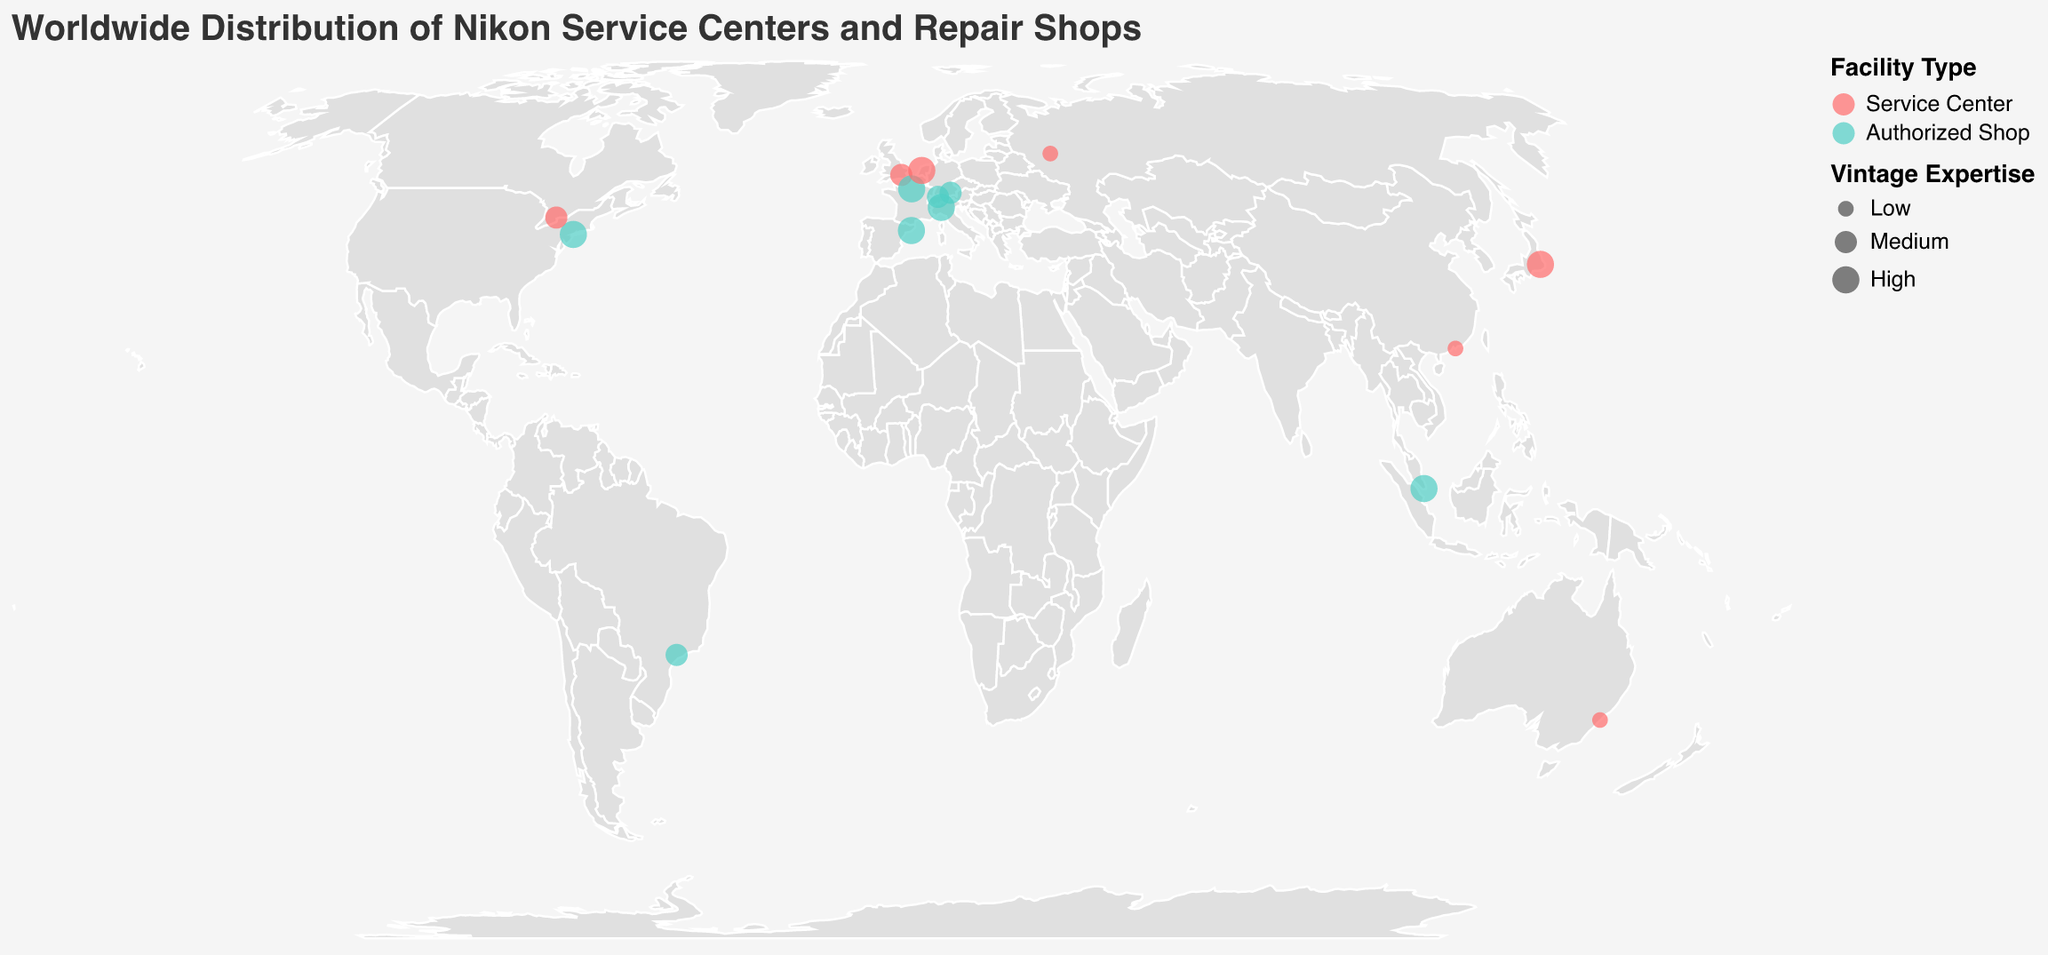Which countries have Nikon-related facilities with high vintage expertise? The "Vintage Expertise" legend in the figure shows that high expertise is represented by the largest circle size. High expertise can be seen in facilities located in Japan, USA, France, Italy, Spain, Netherlands, and Singapore.
Answer: Japan, USA, France, Italy, Spain, Netherlands, Singapore How many service centers are there worldwide? The "Facility Type" legend shows that service centers are in red. By counting the red circles on the map, there are eight service centers: located in Japan, UK, Australia, Canada, Netherlands, Hong Kong, Russia, and the USA.
Answer: 8 Which facility in Europe has the highest vintage expertise? In Europe, the largest circles (indicating high vintage expertise) are in Munich, Paris, Milan, and Amsterdam. Checking the map, Nikon European Center in Amsterdam is a service center, and the others are authorized shops. The facility in Amsterdam is the one with the highest vintage expertise in Europe.
Answer: Nikon European Center Which service center has the lowest vintage expertise? The "Vintage Expertise" legend shows that the smallest circle size represents low expertise. The service centers with the smallest circles are in Sydney, Hong Kong, and Moscow. All three service centers have the lowest vintage expertise.
Answer: Sydney, Hong Kong, Moscow Which city has the largest number of Nikon-related facilities displayed? The tooltip information as you hover reveals that each facility's city name. By counting, only one city, each, hosts the facilities. Therefore, the answer is every city has only 1 Nikon-related facility displayed.
Answer: Each city has 1 Which continent has the highest concentration of high-expertise authorized shops? Checking the map for green circles with the largest size in Europe shows authorized shops in Munich, Paris, Milan, and Zurich. Europe has the highest concentration of high-expertise authorized shops among the other continents.
Answer: Europe Compare the vintage expertise of Nikon facilities between Japan and the USA. Which country offers better expertise on vintage cameras? Focusing on the circle sizes in Japan and the USA, both countries have facilities with large circles (high expertise). Since both Japan's Nikon Plaza Tokyo and USA's Classic Camera Repair have high vintage expertise, they both offer high expertise without one being better than the other.
Answer: Equal 